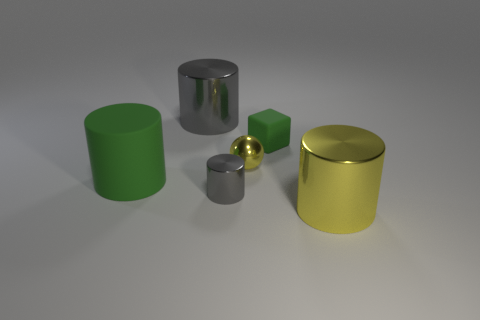Is there a green rubber object of the same shape as the large gray metallic thing?
Your response must be concise. Yes. What number of large objects are either purple spheres or matte cylinders?
Offer a terse response. 1. How many other things are the same color as the tiny sphere?
Keep it short and to the point. 1. What number of yellow balls have the same material as the small gray cylinder?
Your response must be concise. 1. Do the large metal thing right of the large gray metallic thing and the tiny ball have the same color?
Make the answer very short. Yes. What number of green things are either metallic things or metallic balls?
Your answer should be compact. 0. Is the material of the green thing left of the yellow ball the same as the small yellow ball?
Keep it short and to the point. No. How many things are gray things or large cylinders that are on the left side of the small yellow metallic thing?
Your response must be concise. 3. What number of metallic cylinders are to the right of the large metal object that is behind the green object on the left side of the big gray shiny thing?
Your response must be concise. 2. There is a green rubber thing on the left side of the tiny green cube; is it the same shape as the tiny gray object?
Provide a succinct answer. Yes. 